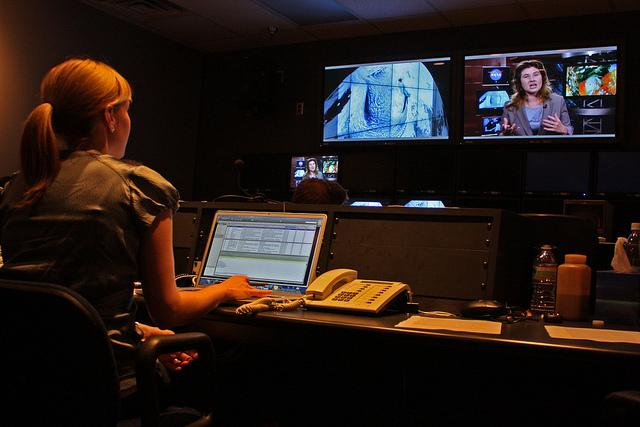What is the woman doing? Please explain your reasoning. working. The woman is sitting behind a laptop that has an excel type document up. both tools would be something frequently associated with answer a and she looks like she is really focused. 